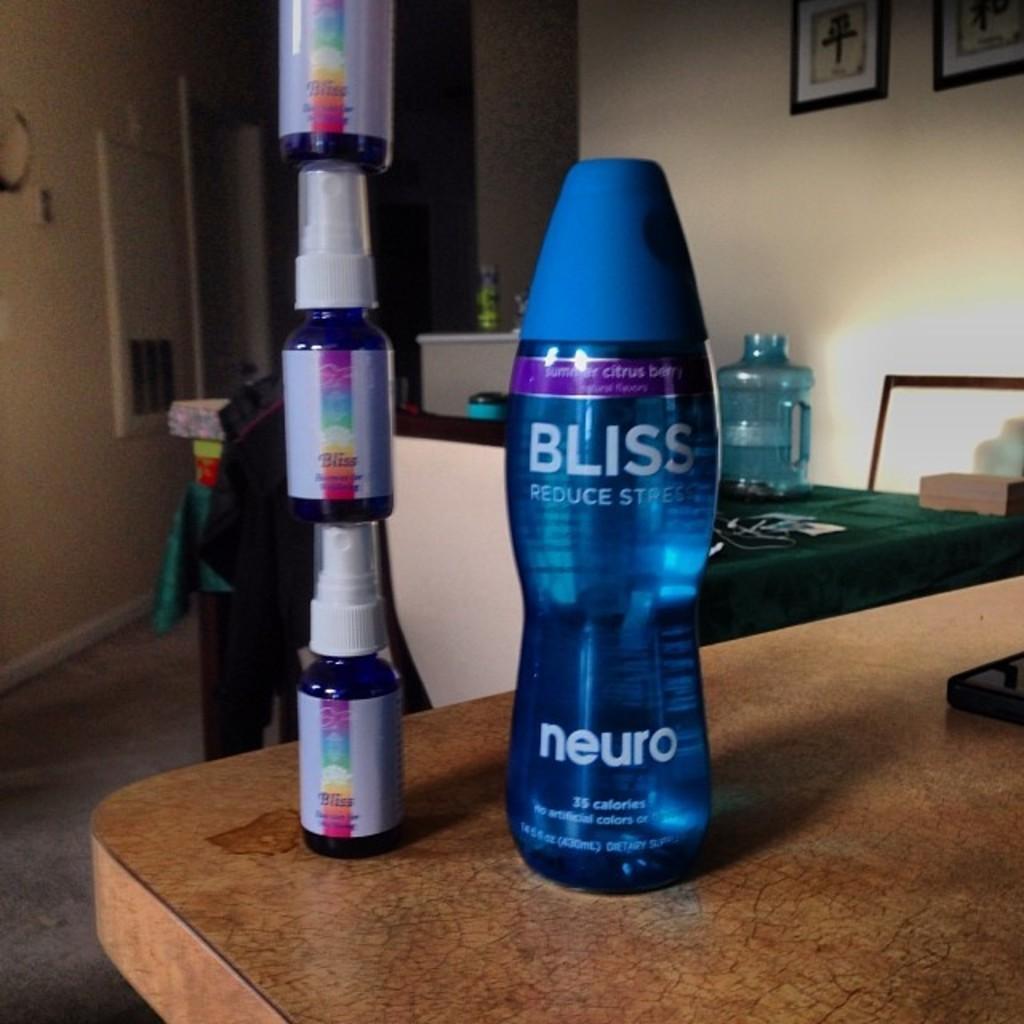Could you give a brief overview of what you see in this image? I can see in this image there is a border and two objects on the table. I can see there is a few photos on a white wall. 